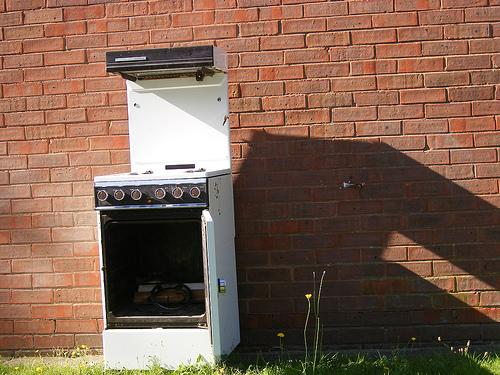Mention two light-related features observed in the image. The sunlight casting a shadow of the oven on the grass and the wall, and the light hitting the object at some parts. Is the oven in a typical indoor or outdoor setting and what evidence supports your answer? The oven is in an outdoor setting because it is placed on grass with a tall dandelion growing nearby. Describe the relationship between the main object and its surrounding environment in the image. The white oven stands out against the green grass, and its shadow creates a connection between itself and the red brick wall. In layman's terms, briefly describe the setting of the image. A white oven with no door and black knobs is sitting on green grass, with a red brick wall behind it and a yellow flower nearby. How many knobs are there on the oven and what color are they? There are six knobs on the oven, and they are black. Provide a detailed description of the wall in the image. The wall in the image is made of red bricks with a contrasting tone of light and dark areas, casting a shadow due to sunlight. How would you describe the atmosphere of the image in one word? Surreal. Identify the main colors of the scene in the image. The main colors are white (oven), green (grass), red (brick wall), and black (knobs). In a poetic style, write a sentence about the flower in the image. Amidst the verdant meadow, a tall dandelion gently sways, bearing a little sun, a yellow flower full of grace. What is the main object in the image and what is its main characteristic? The main object is an old white oven, with its door missing and placed outdoors on the grass. What color is the kitchen appliance in the image? White Describe an activity occurring in the image. There is a dandelion growing near the oven. Identify the type of appliance shown in the image. An oven (or a stove) Describe a visual element that shows this oven is used outdoors. There is grass on the ground around the oven. Find three colors present in the image. White, red, and green Write an eye-catching caption for this image that could be used on social media. "Old, door-less oven meets nature: a unique fusion of kitchen appliances and the great outdoors! 🌼⚙️" Briefly describe the oven's appearance. The oven is white, old, and missing its door, revealing a dark interior. Which statement is true about the flowers in the image? a) They are pink, b) They are dandelions, c) They are roses, d) There are no flowers in the image b) They are dandelions Choose the correct statement about the oven in the image: a) The oven door is missing, b) The oven has a blue door, c) The oven has a digital timer, d) The oven is in a room with wooden walls a) The oven door is missing Based on this image, what kind of environment is the oven in? The oven is in an outdoor environment with a red brick wall and grass. Determine the event taking place in the image. There is no specific event; it displays an old oven outdoors. Explain the relationship between the oven and the wall. The oven sits outside with a red brick wall behind it. Describe the knobs on the oven. The knobs are black and round, located on the top front part of the oven. Explain a unique feature of the oven's location. The oven is placed outside on grass, which is unusual for kitchen appliances. Describe the wall in the image. The wall is made of red bricks and covers a significant portion of the background of the image. Identify the type of flower shown in the image. Dandelion Identify the type of building material used for the wall in the image. Red brick Describe the ground where the oven is placed. The ground is covered with green grass. Create a short poem inspired by the elements present in this image. "Amidst the grass so green, 